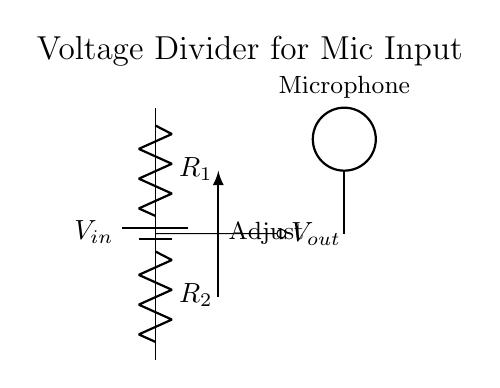What does the variable Vin represent? Vin is the input voltage to the circuit, which powers the entire voltage divider. It can be any voltage source connected to the circuit.
Answer: Vin What are the values of the resistors in the circuit? The resistors R1 and R2 are depicted in the circuit, but their exact values are not specified in the diagram. They can vary based on the desired output voltage.
Answer: R1, R2 What is the purpose of the voltage divider in this circuit? The voltage divider's purpose is to reduce the input voltage to a lower output voltage suitable for the microphone's input level. This adjustment is important to prevent distortion or damage to the microphone.
Answer: Adjust input voltage How do you calculate the output voltage Vout? Vout can be calculated using the formula Vout = Vin * (R2 / (R1 + R2)). This equation shows that the output voltage is a fraction of the input voltage based on the resistor values.
Answer: Vout = Vin * (R2 / (R1 + R2)) What is the position of the microphone in relation to the circuit? The microphone is positioned to receive the output voltage Vout from the voltage divider. It is shown connected at the output node, making it the recipient of the adjusted signal.
Answer: At the output node What is indicated by the arrow labeled "Adjust"? The arrow labeled "Adjust" indicates that there is a mechanism to change the resistance values of R1 or R2, which will modify the output voltage Vout, allowing for fine-tuning of the microphone input level.
Answer: Resistance adjustment 